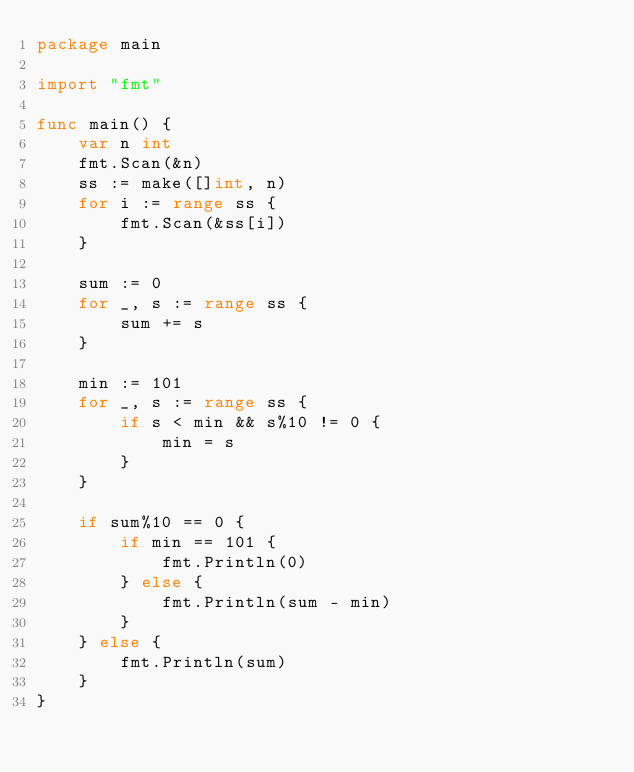Convert code to text. <code><loc_0><loc_0><loc_500><loc_500><_Go_>package main

import "fmt"

func main() {
	var n int
	fmt.Scan(&n)
	ss := make([]int, n)
	for i := range ss {
		fmt.Scan(&ss[i])
	}

	sum := 0
	for _, s := range ss {
		sum += s
	}

	min := 101
	for _, s := range ss {
		if s < min && s%10 != 0 {
			min = s
		}
	}

	if sum%10 == 0 {
		if min == 101 {
			fmt.Println(0)
		} else {
			fmt.Println(sum - min)
		}
	} else {
		fmt.Println(sum)
	}
}
</code> 